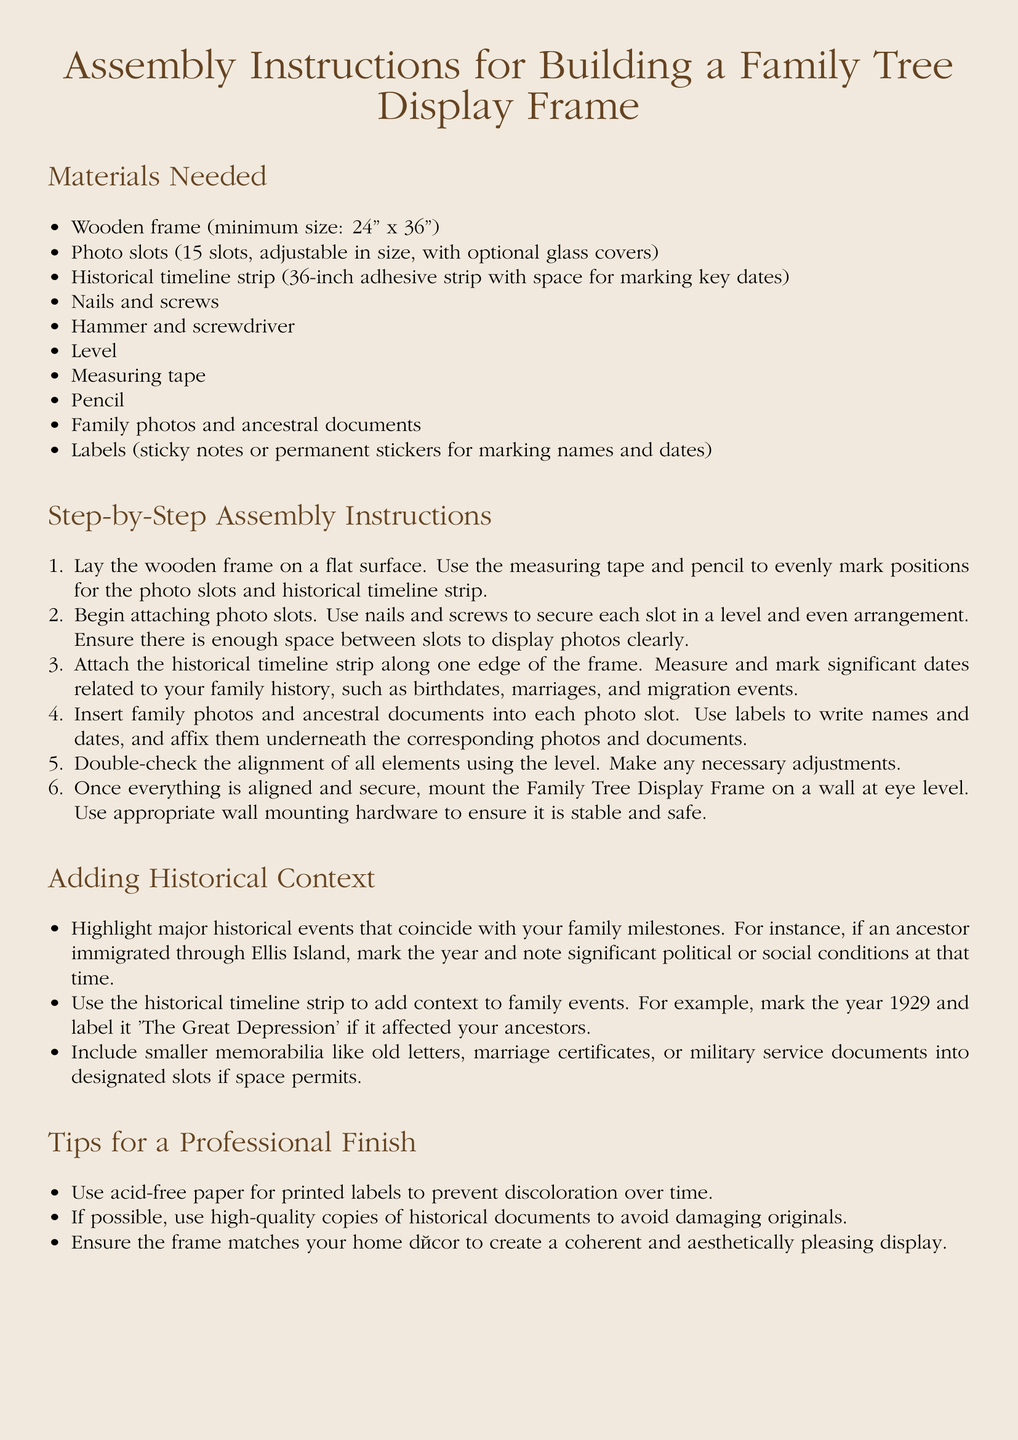What is the minimum size of the wooden frame? The document specifies that the wooden frame should have a minimum size of 24 inches by 36 inches.
Answer: 24" x 36" How many photo slots are needed? The assembly instructions state that you need 15 photo slots for the frame.
Answer: 15 slots What type of paper should be used for printed labels? The document advises using acid-free paper for printed labels to prevent discoloration over time.
Answer: Acid-free paper Which tool is used to secure the photo slots? The instructions mention that nails and screws are used to secure each photo slot.
Answer: Nails and screws What must be attached along one edge of the frame? According to the instructions, a historical timeline strip must be attached along one edge of the frame.
Answer: Historical timeline strip What should you double-check for alignment? The instructions indicate to double-check the alignment of all elements using a level.
Answer: Level What year should be marked for the Great Depression? The document suggests marking the year 1929 as an important historical event related to family events.
Answer: 1929 What type of documents can be included in designated slots? The document mentions including smaller memorabilia like old letters and marriage certificates into designated slots if space permits.
Answer: Old letters, marriage certificates What is the color of the page background? The document specifies that the page color is light brown at 30% opacity.
Answer: Light brown!30 